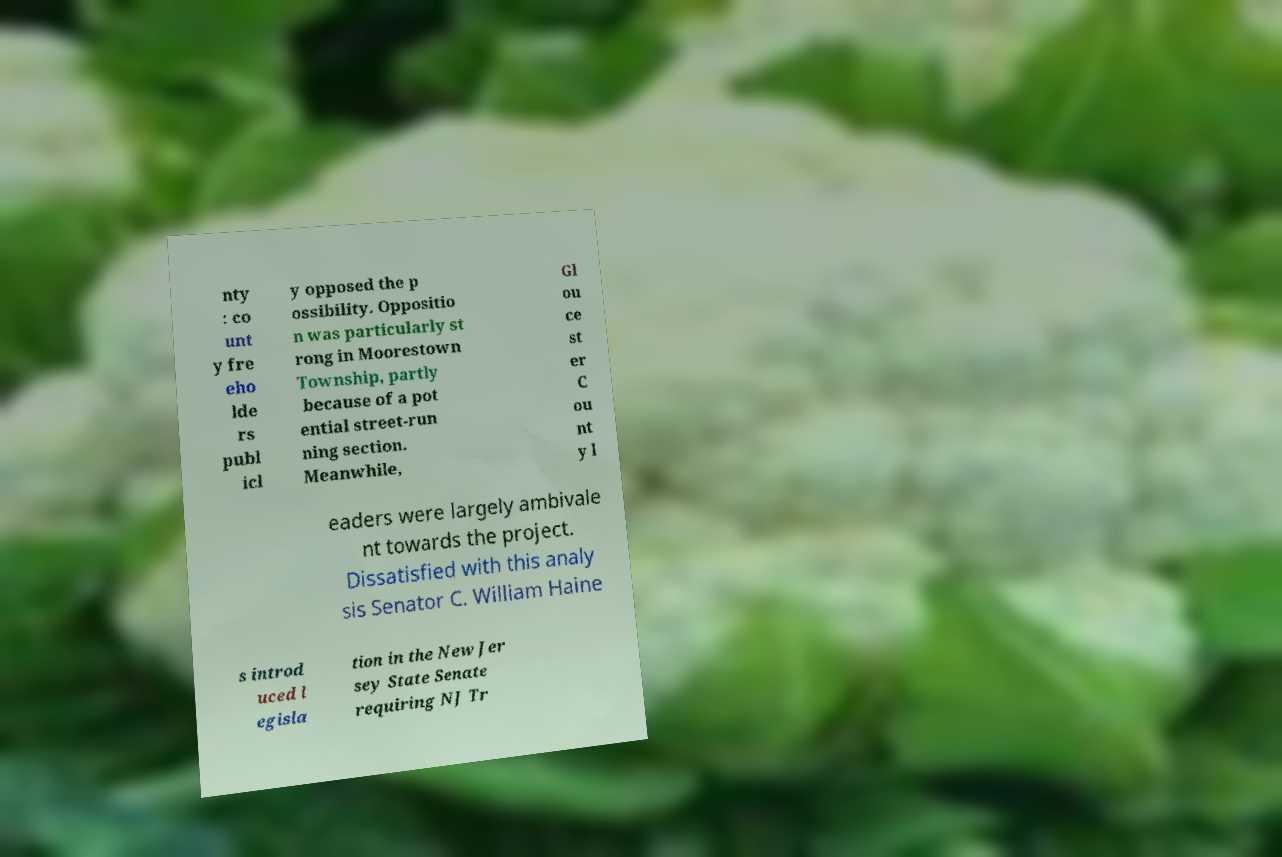For documentation purposes, I need the text within this image transcribed. Could you provide that? nty : co unt y fre eho lde rs publ icl y opposed the p ossibility. Oppositio n was particularly st rong in Moorestown Township, partly because of a pot ential street-run ning section. Meanwhile, Gl ou ce st er C ou nt y l eaders were largely ambivale nt towards the project. Dissatisfied with this analy sis Senator C. William Haine s introd uced l egisla tion in the New Jer sey State Senate requiring NJ Tr 